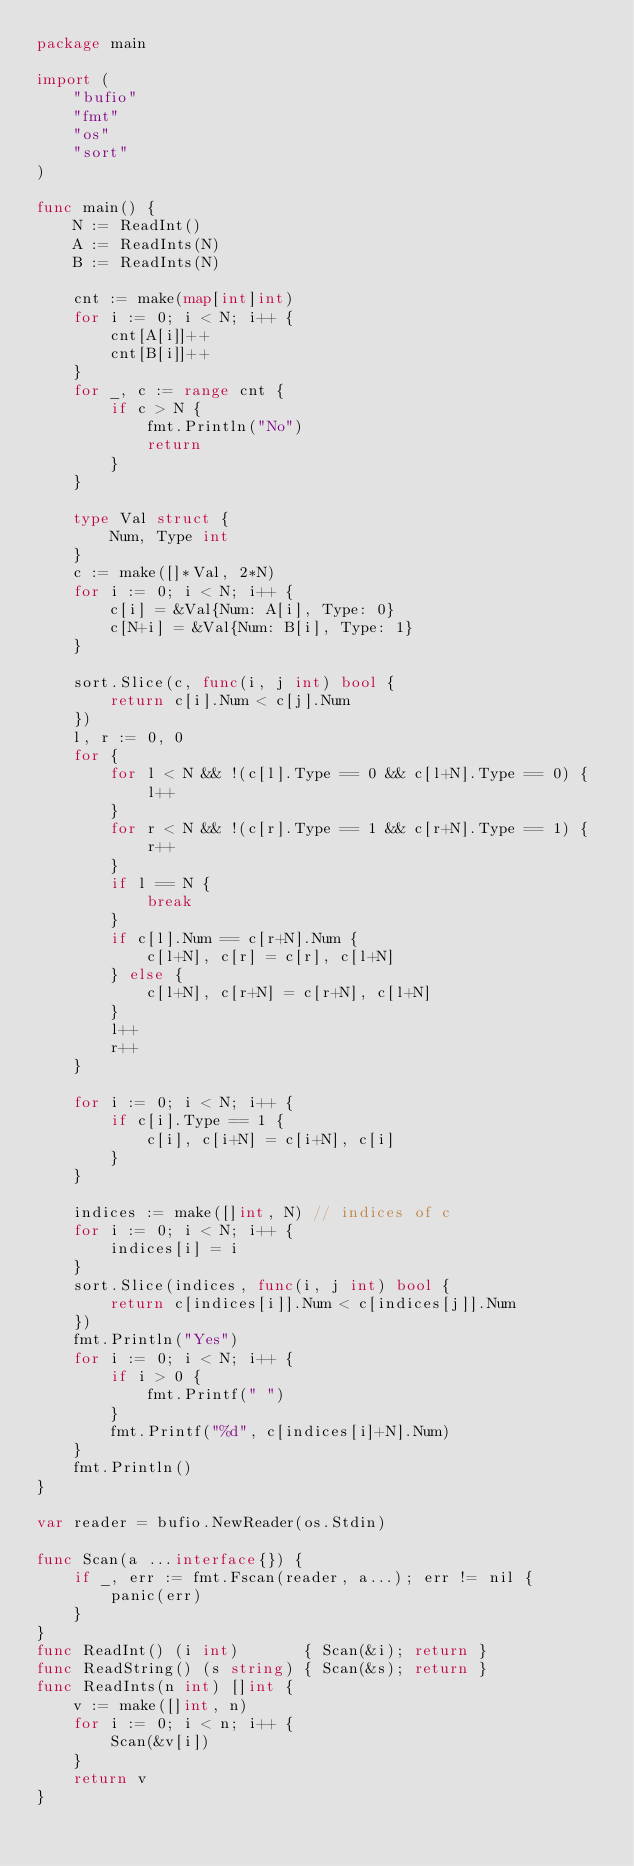<code> <loc_0><loc_0><loc_500><loc_500><_Go_>package main

import (
	"bufio"
	"fmt"
	"os"
	"sort"
)

func main() {
	N := ReadInt()
	A := ReadInts(N)
	B := ReadInts(N)

	cnt := make(map[int]int)
	for i := 0; i < N; i++ {
		cnt[A[i]]++
		cnt[B[i]]++
	}
	for _, c := range cnt {
		if c > N {
			fmt.Println("No")
			return
		}
	}

	type Val struct {
		Num, Type int
	}
	c := make([]*Val, 2*N)
	for i := 0; i < N; i++ {
		c[i] = &Val{Num: A[i], Type: 0}
		c[N+i] = &Val{Num: B[i], Type: 1}
	}

	sort.Slice(c, func(i, j int) bool {
		return c[i].Num < c[j].Num
	})
	l, r := 0, 0
	for {
		for l < N && !(c[l].Type == 0 && c[l+N].Type == 0) {
			l++
		}
		for r < N && !(c[r].Type == 1 && c[r+N].Type == 1) {
			r++
		}
		if l == N {
			break
		}
		if c[l].Num == c[r+N].Num {
			c[l+N], c[r] = c[r], c[l+N]
		} else {
			c[l+N], c[r+N] = c[r+N], c[l+N]
		}
		l++
		r++
	}

	for i := 0; i < N; i++ {
		if c[i].Type == 1 {
			c[i], c[i+N] = c[i+N], c[i]
		}
	}

	indices := make([]int, N) // indices of c
	for i := 0; i < N; i++ {
		indices[i] = i
	}
	sort.Slice(indices, func(i, j int) bool {
		return c[indices[i]].Num < c[indices[j]].Num
	})
	fmt.Println("Yes")
	for i := 0; i < N; i++ {
		if i > 0 {
			fmt.Printf(" ")
		}
		fmt.Printf("%d", c[indices[i]+N].Num)
	}
	fmt.Println()
}

var reader = bufio.NewReader(os.Stdin)

func Scan(a ...interface{}) {
	if _, err := fmt.Fscan(reader, a...); err != nil {
		panic(err)
	}
}
func ReadInt() (i int)       { Scan(&i); return }
func ReadString() (s string) { Scan(&s); return }
func ReadInts(n int) []int {
	v := make([]int, n)
	for i := 0; i < n; i++ {
		Scan(&v[i])
	}
	return v
}
</code> 